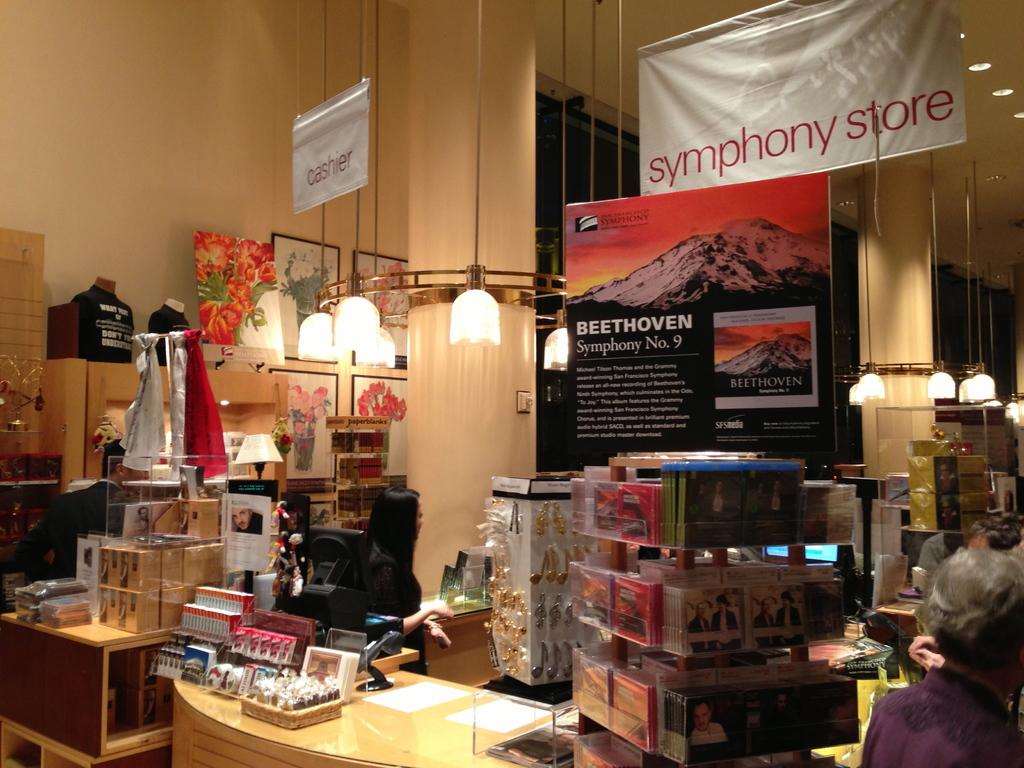<image>
Write a terse but informative summary of the picture. the interior of a shop entitled Symphony Store with a display of Beethoven 